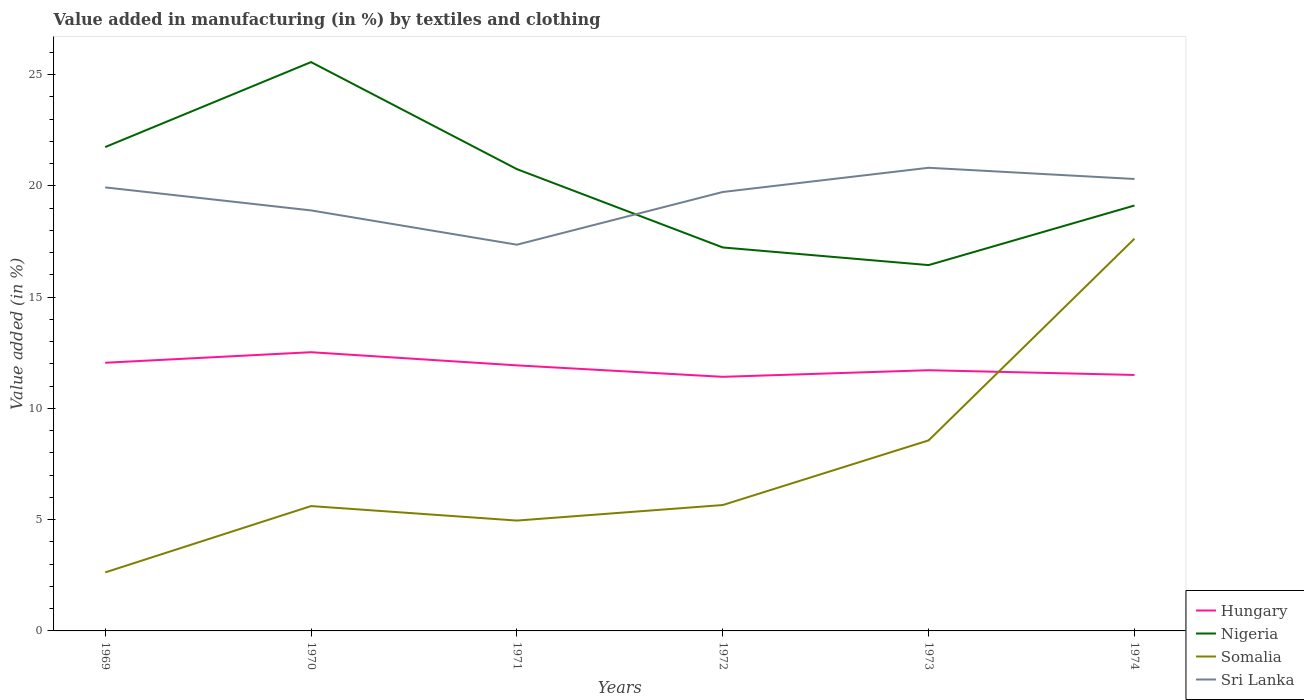How many different coloured lines are there?
Offer a very short reply. 4. Across all years, what is the maximum percentage of value added in manufacturing by textiles and clothing in Sri Lanka?
Ensure brevity in your answer.  17.36. What is the total percentage of value added in manufacturing by textiles and clothing in Somalia in the graph?
Offer a very short reply. -2.91. What is the difference between the highest and the second highest percentage of value added in manufacturing by textiles and clothing in Sri Lanka?
Provide a short and direct response. 3.46. How many lines are there?
Your answer should be compact. 4. How many years are there in the graph?
Keep it short and to the point. 6. Are the values on the major ticks of Y-axis written in scientific E-notation?
Your response must be concise. No. Where does the legend appear in the graph?
Provide a succinct answer. Bottom right. How many legend labels are there?
Give a very brief answer. 4. How are the legend labels stacked?
Your response must be concise. Vertical. What is the title of the graph?
Keep it short and to the point. Value added in manufacturing (in %) by textiles and clothing. Does "Marshall Islands" appear as one of the legend labels in the graph?
Give a very brief answer. No. What is the label or title of the X-axis?
Offer a very short reply. Years. What is the label or title of the Y-axis?
Your answer should be very brief. Value added (in %). What is the Value added (in %) in Hungary in 1969?
Your response must be concise. 12.05. What is the Value added (in %) of Nigeria in 1969?
Keep it short and to the point. 21.75. What is the Value added (in %) in Somalia in 1969?
Keep it short and to the point. 2.63. What is the Value added (in %) in Sri Lanka in 1969?
Offer a very short reply. 19.93. What is the Value added (in %) of Hungary in 1970?
Ensure brevity in your answer.  12.53. What is the Value added (in %) in Nigeria in 1970?
Offer a terse response. 25.57. What is the Value added (in %) in Somalia in 1970?
Your response must be concise. 5.61. What is the Value added (in %) of Sri Lanka in 1970?
Provide a succinct answer. 18.9. What is the Value added (in %) of Hungary in 1971?
Your answer should be compact. 11.94. What is the Value added (in %) in Nigeria in 1971?
Give a very brief answer. 20.75. What is the Value added (in %) of Somalia in 1971?
Make the answer very short. 4.96. What is the Value added (in %) of Sri Lanka in 1971?
Your response must be concise. 17.36. What is the Value added (in %) of Hungary in 1972?
Offer a very short reply. 11.42. What is the Value added (in %) of Nigeria in 1972?
Provide a short and direct response. 17.23. What is the Value added (in %) in Somalia in 1972?
Provide a short and direct response. 5.66. What is the Value added (in %) of Sri Lanka in 1972?
Your response must be concise. 19.73. What is the Value added (in %) in Hungary in 1973?
Your answer should be compact. 11.72. What is the Value added (in %) in Nigeria in 1973?
Your response must be concise. 16.44. What is the Value added (in %) of Somalia in 1973?
Ensure brevity in your answer.  8.56. What is the Value added (in %) in Sri Lanka in 1973?
Ensure brevity in your answer.  20.82. What is the Value added (in %) of Hungary in 1974?
Your answer should be compact. 11.5. What is the Value added (in %) in Nigeria in 1974?
Offer a terse response. 19.12. What is the Value added (in %) in Somalia in 1974?
Offer a terse response. 17.63. What is the Value added (in %) in Sri Lanka in 1974?
Provide a succinct answer. 20.31. Across all years, what is the maximum Value added (in %) of Hungary?
Offer a terse response. 12.53. Across all years, what is the maximum Value added (in %) in Nigeria?
Ensure brevity in your answer.  25.57. Across all years, what is the maximum Value added (in %) of Somalia?
Your answer should be compact. 17.63. Across all years, what is the maximum Value added (in %) of Sri Lanka?
Your answer should be compact. 20.82. Across all years, what is the minimum Value added (in %) of Hungary?
Make the answer very short. 11.42. Across all years, what is the minimum Value added (in %) of Nigeria?
Offer a very short reply. 16.44. Across all years, what is the minimum Value added (in %) in Somalia?
Your answer should be very brief. 2.63. Across all years, what is the minimum Value added (in %) of Sri Lanka?
Ensure brevity in your answer.  17.36. What is the total Value added (in %) in Hungary in the graph?
Your answer should be very brief. 71.15. What is the total Value added (in %) of Nigeria in the graph?
Make the answer very short. 120.86. What is the total Value added (in %) of Somalia in the graph?
Provide a short and direct response. 45.05. What is the total Value added (in %) of Sri Lanka in the graph?
Provide a succinct answer. 117.05. What is the difference between the Value added (in %) in Hungary in 1969 and that in 1970?
Your response must be concise. -0.47. What is the difference between the Value added (in %) in Nigeria in 1969 and that in 1970?
Give a very brief answer. -3.82. What is the difference between the Value added (in %) of Somalia in 1969 and that in 1970?
Provide a succinct answer. -2.98. What is the difference between the Value added (in %) of Sri Lanka in 1969 and that in 1970?
Your answer should be very brief. 1.03. What is the difference between the Value added (in %) in Hungary in 1969 and that in 1971?
Offer a very short reply. 0.12. What is the difference between the Value added (in %) in Nigeria in 1969 and that in 1971?
Provide a succinct answer. 0.99. What is the difference between the Value added (in %) of Somalia in 1969 and that in 1971?
Give a very brief answer. -2.33. What is the difference between the Value added (in %) of Sri Lanka in 1969 and that in 1971?
Offer a very short reply. 2.58. What is the difference between the Value added (in %) of Hungary in 1969 and that in 1972?
Offer a very short reply. 0.63. What is the difference between the Value added (in %) of Nigeria in 1969 and that in 1972?
Your response must be concise. 4.51. What is the difference between the Value added (in %) of Somalia in 1969 and that in 1972?
Your response must be concise. -3.03. What is the difference between the Value added (in %) of Sri Lanka in 1969 and that in 1972?
Ensure brevity in your answer.  0.21. What is the difference between the Value added (in %) of Hungary in 1969 and that in 1973?
Offer a terse response. 0.34. What is the difference between the Value added (in %) of Nigeria in 1969 and that in 1973?
Give a very brief answer. 5.31. What is the difference between the Value added (in %) in Somalia in 1969 and that in 1973?
Offer a terse response. -5.93. What is the difference between the Value added (in %) in Sri Lanka in 1969 and that in 1973?
Provide a succinct answer. -0.88. What is the difference between the Value added (in %) in Hungary in 1969 and that in 1974?
Provide a succinct answer. 0.55. What is the difference between the Value added (in %) in Nigeria in 1969 and that in 1974?
Provide a short and direct response. 2.63. What is the difference between the Value added (in %) in Somalia in 1969 and that in 1974?
Provide a short and direct response. -15. What is the difference between the Value added (in %) in Sri Lanka in 1969 and that in 1974?
Your response must be concise. -0.38. What is the difference between the Value added (in %) of Hungary in 1970 and that in 1971?
Ensure brevity in your answer.  0.59. What is the difference between the Value added (in %) in Nigeria in 1970 and that in 1971?
Offer a very short reply. 4.81. What is the difference between the Value added (in %) of Somalia in 1970 and that in 1971?
Keep it short and to the point. 0.65. What is the difference between the Value added (in %) in Sri Lanka in 1970 and that in 1971?
Your response must be concise. 1.54. What is the difference between the Value added (in %) in Hungary in 1970 and that in 1972?
Ensure brevity in your answer.  1.11. What is the difference between the Value added (in %) of Nigeria in 1970 and that in 1972?
Provide a short and direct response. 8.33. What is the difference between the Value added (in %) in Somalia in 1970 and that in 1972?
Your answer should be compact. -0.05. What is the difference between the Value added (in %) in Sri Lanka in 1970 and that in 1972?
Offer a very short reply. -0.83. What is the difference between the Value added (in %) in Hungary in 1970 and that in 1973?
Offer a very short reply. 0.81. What is the difference between the Value added (in %) in Nigeria in 1970 and that in 1973?
Your answer should be very brief. 9.12. What is the difference between the Value added (in %) in Somalia in 1970 and that in 1973?
Keep it short and to the point. -2.95. What is the difference between the Value added (in %) of Sri Lanka in 1970 and that in 1973?
Give a very brief answer. -1.92. What is the difference between the Value added (in %) of Hungary in 1970 and that in 1974?
Keep it short and to the point. 1.02. What is the difference between the Value added (in %) in Nigeria in 1970 and that in 1974?
Your answer should be compact. 6.45. What is the difference between the Value added (in %) in Somalia in 1970 and that in 1974?
Give a very brief answer. -12.02. What is the difference between the Value added (in %) in Sri Lanka in 1970 and that in 1974?
Your answer should be very brief. -1.41. What is the difference between the Value added (in %) of Hungary in 1971 and that in 1972?
Make the answer very short. 0.52. What is the difference between the Value added (in %) in Nigeria in 1971 and that in 1972?
Your answer should be compact. 3.52. What is the difference between the Value added (in %) of Somalia in 1971 and that in 1972?
Ensure brevity in your answer.  -0.7. What is the difference between the Value added (in %) of Sri Lanka in 1971 and that in 1972?
Your answer should be compact. -2.37. What is the difference between the Value added (in %) in Hungary in 1971 and that in 1973?
Offer a terse response. 0.22. What is the difference between the Value added (in %) of Nigeria in 1971 and that in 1973?
Offer a terse response. 4.31. What is the difference between the Value added (in %) in Somalia in 1971 and that in 1973?
Your response must be concise. -3.6. What is the difference between the Value added (in %) in Sri Lanka in 1971 and that in 1973?
Give a very brief answer. -3.46. What is the difference between the Value added (in %) of Hungary in 1971 and that in 1974?
Provide a short and direct response. 0.43. What is the difference between the Value added (in %) of Nigeria in 1971 and that in 1974?
Provide a succinct answer. 1.64. What is the difference between the Value added (in %) in Somalia in 1971 and that in 1974?
Provide a succinct answer. -12.67. What is the difference between the Value added (in %) in Sri Lanka in 1971 and that in 1974?
Give a very brief answer. -2.95. What is the difference between the Value added (in %) of Hungary in 1972 and that in 1973?
Offer a very short reply. -0.3. What is the difference between the Value added (in %) in Nigeria in 1972 and that in 1973?
Give a very brief answer. 0.79. What is the difference between the Value added (in %) in Somalia in 1972 and that in 1973?
Your answer should be very brief. -2.91. What is the difference between the Value added (in %) in Sri Lanka in 1972 and that in 1973?
Keep it short and to the point. -1.09. What is the difference between the Value added (in %) in Hungary in 1972 and that in 1974?
Keep it short and to the point. -0.08. What is the difference between the Value added (in %) of Nigeria in 1972 and that in 1974?
Provide a succinct answer. -1.88. What is the difference between the Value added (in %) in Somalia in 1972 and that in 1974?
Make the answer very short. -11.97. What is the difference between the Value added (in %) in Sri Lanka in 1972 and that in 1974?
Your answer should be compact. -0.58. What is the difference between the Value added (in %) of Hungary in 1973 and that in 1974?
Provide a succinct answer. 0.21. What is the difference between the Value added (in %) of Nigeria in 1973 and that in 1974?
Provide a succinct answer. -2.68. What is the difference between the Value added (in %) of Somalia in 1973 and that in 1974?
Give a very brief answer. -9.07. What is the difference between the Value added (in %) in Sri Lanka in 1973 and that in 1974?
Offer a terse response. 0.5. What is the difference between the Value added (in %) of Hungary in 1969 and the Value added (in %) of Nigeria in 1970?
Provide a short and direct response. -13.51. What is the difference between the Value added (in %) in Hungary in 1969 and the Value added (in %) in Somalia in 1970?
Offer a very short reply. 6.44. What is the difference between the Value added (in %) in Hungary in 1969 and the Value added (in %) in Sri Lanka in 1970?
Provide a short and direct response. -6.85. What is the difference between the Value added (in %) of Nigeria in 1969 and the Value added (in %) of Somalia in 1970?
Keep it short and to the point. 16.14. What is the difference between the Value added (in %) of Nigeria in 1969 and the Value added (in %) of Sri Lanka in 1970?
Make the answer very short. 2.85. What is the difference between the Value added (in %) in Somalia in 1969 and the Value added (in %) in Sri Lanka in 1970?
Your answer should be compact. -16.27. What is the difference between the Value added (in %) in Hungary in 1969 and the Value added (in %) in Nigeria in 1971?
Your answer should be compact. -8.7. What is the difference between the Value added (in %) in Hungary in 1969 and the Value added (in %) in Somalia in 1971?
Keep it short and to the point. 7.09. What is the difference between the Value added (in %) of Hungary in 1969 and the Value added (in %) of Sri Lanka in 1971?
Your answer should be very brief. -5.31. What is the difference between the Value added (in %) of Nigeria in 1969 and the Value added (in %) of Somalia in 1971?
Make the answer very short. 16.79. What is the difference between the Value added (in %) in Nigeria in 1969 and the Value added (in %) in Sri Lanka in 1971?
Give a very brief answer. 4.39. What is the difference between the Value added (in %) in Somalia in 1969 and the Value added (in %) in Sri Lanka in 1971?
Your response must be concise. -14.73. What is the difference between the Value added (in %) of Hungary in 1969 and the Value added (in %) of Nigeria in 1972?
Keep it short and to the point. -5.18. What is the difference between the Value added (in %) in Hungary in 1969 and the Value added (in %) in Somalia in 1972?
Offer a terse response. 6.39. What is the difference between the Value added (in %) of Hungary in 1969 and the Value added (in %) of Sri Lanka in 1972?
Provide a short and direct response. -7.68. What is the difference between the Value added (in %) of Nigeria in 1969 and the Value added (in %) of Somalia in 1972?
Keep it short and to the point. 16.09. What is the difference between the Value added (in %) of Nigeria in 1969 and the Value added (in %) of Sri Lanka in 1972?
Keep it short and to the point. 2.02. What is the difference between the Value added (in %) in Somalia in 1969 and the Value added (in %) in Sri Lanka in 1972?
Your answer should be compact. -17.1. What is the difference between the Value added (in %) in Hungary in 1969 and the Value added (in %) in Nigeria in 1973?
Your answer should be very brief. -4.39. What is the difference between the Value added (in %) of Hungary in 1969 and the Value added (in %) of Somalia in 1973?
Your answer should be compact. 3.49. What is the difference between the Value added (in %) in Hungary in 1969 and the Value added (in %) in Sri Lanka in 1973?
Your answer should be compact. -8.76. What is the difference between the Value added (in %) of Nigeria in 1969 and the Value added (in %) of Somalia in 1973?
Give a very brief answer. 13.18. What is the difference between the Value added (in %) of Nigeria in 1969 and the Value added (in %) of Sri Lanka in 1973?
Offer a terse response. 0.93. What is the difference between the Value added (in %) of Somalia in 1969 and the Value added (in %) of Sri Lanka in 1973?
Your response must be concise. -18.19. What is the difference between the Value added (in %) in Hungary in 1969 and the Value added (in %) in Nigeria in 1974?
Give a very brief answer. -7.07. What is the difference between the Value added (in %) in Hungary in 1969 and the Value added (in %) in Somalia in 1974?
Give a very brief answer. -5.58. What is the difference between the Value added (in %) of Hungary in 1969 and the Value added (in %) of Sri Lanka in 1974?
Keep it short and to the point. -8.26. What is the difference between the Value added (in %) of Nigeria in 1969 and the Value added (in %) of Somalia in 1974?
Offer a very short reply. 4.12. What is the difference between the Value added (in %) of Nigeria in 1969 and the Value added (in %) of Sri Lanka in 1974?
Your response must be concise. 1.43. What is the difference between the Value added (in %) in Somalia in 1969 and the Value added (in %) in Sri Lanka in 1974?
Your answer should be very brief. -17.68. What is the difference between the Value added (in %) of Hungary in 1970 and the Value added (in %) of Nigeria in 1971?
Keep it short and to the point. -8.23. What is the difference between the Value added (in %) of Hungary in 1970 and the Value added (in %) of Somalia in 1971?
Keep it short and to the point. 7.57. What is the difference between the Value added (in %) in Hungary in 1970 and the Value added (in %) in Sri Lanka in 1971?
Provide a succinct answer. -4.83. What is the difference between the Value added (in %) of Nigeria in 1970 and the Value added (in %) of Somalia in 1971?
Your answer should be compact. 20.61. What is the difference between the Value added (in %) of Nigeria in 1970 and the Value added (in %) of Sri Lanka in 1971?
Keep it short and to the point. 8.21. What is the difference between the Value added (in %) of Somalia in 1970 and the Value added (in %) of Sri Lanka in 1971?
Give a very brief answer. -11.75. What is the difference between the Value added (in %) in Hungary in 1970 and the Value added (in %) in Nigeria in 1972?
Provide a short and direct response. -4.71. What is the difference between the Value added (in %) in Hungary in 1970 and the Value added (in %) in Somalia in 1972?
Offer a terse response. 6.87. What is the difference between the Value added (in %) of Hungary in 1970 and the Value added (in %) of Sri Lanka in 1972?
Provide a short and direct response. -7.2. What is the difference between the Value added (in %) of Nigeria in 1970 and the Value added (in %) of Somalia in 1972?
Your answer should be compact. 19.91. What is the difference between the Value added (in %) in Nigeria in 1970 and the Value added (in %) in Sri Lanka in 1972?
Your response must be concise. 5.84. What is the difference between the Value added (in %) of Somalia in 1970 and the Value added (in %) of Sri Lanka in 1972?
Offer a very short reply. -14.12. What is the difference between the Value added (in %) of Hungary in 1970 and the Value added (in %) of Nigeria in 1973?
Give a very brief answer. -3.92. What is the difference between the Value added (in %) of Hungary in 1970 and the Value added (in %) of Somalia in 1973?
Your answer should be compact. 3.96. What is the difference between the Value added (in %) of Hungary in 1970 and the Value added (in %) of Sri Lanka in 1973?
Offer a terse response. -8.29. What is the difference between the Value added (in %) in Nigeria in 1970 and the Value added (in %) in Somalia in 1973?
Offer a very short reply. 17. What is the difference between the Value added (in %) of Nigeria in 1970 and the Value added (in %) of Sri Lanka in 1973?
Your answer should be very brief. 4.75. What is the difference between the Value added (in %) in Somalia in 1970 and the Value added (in %) in Sri Lanka in 1973?
Your response must be concise. -15.2. What is the difference between the Value added (in %) of Hungary in 1970 and the Value added (in %) of Nigeria in 1974?
Provide a succinct answer. -6.59. What is the difference between the Value added (in %) of Hungary in 1970 and the Value added (in %) of Somalia in 1974?
Make the answer very short. -5.1. What is the difference between the Value added (in %) of Hungary in 1970 and the Value added (in %) of Sri Lanka in 1974?
Your response must be concise. -7.79. What is the difference between the Value added (in %) of Nigeria in 1970 and the Value added (in %) of Somalia in 1974?
Your answer should be very brief. 7.94. What is the difference between the Value added (in %) of Nigeria in 1970 and the Value added (in %) of Sri Lanka in 1974?
Offer a terse response. 5.25. What is the difference between the Value added (in %) of Somalia in 1970 and the Value added (in %) of Sri Lanka in 1974?
Provide a succinct answer. -14.7. What is the difference between the Value added (in %) in Hungary in 1971 and the Value added (in %) in Nigeria in 1972?
Your answer should be very brief. -5.3. What is the difference between the Value added (in %) of Hungary in 1971 and the Value added (in %) of Somalia in 1972?
Offer a terse response. 6.28. What is the difference between the Value added (in %) in Hungary in 1971 and the Value added (in %) in Sri Lanka in 1972?
Your response must be concise. -7.79. What is the difference between the Value added (in %) of Nigeria in 1971 and the Value added (in %) of Somalia in 1972?
Provide a succinct answer. 15.1. What is the difference between the Value added (in %) in Nigeria in 1971 and the Value added (in %) in Sri Lanka in 1972?
Keep it short and to the point. 1.03. What is the difference between the Value added (in %) of Somalia in 1971 and the Value added (in %) of Sri Lanka in 1972?
Keep it short and to the point. -14.77. What is the difference between the Value added (in %) of Hungary in 1971 and the Value added (in %) of Nigeria in 1973?
Offer a terse response. -4.51. What is the difference between the Value added (in %) in Hungary in 1971 and the Value added (in %) in Somalia in 1973?
Ensure brevity in your answer.  3.37. What is the difference between the Value added (in %) of Hungary in 1971 and the Value added (in %) of Sri Lanka in 1973?
Your answer should be very brief. -8.88. What is the difference between the Value added (in %) in Nigeria in 1971 and the Value added (in %) in Somalia in 1973?
Give a very brief answer. 12.19. What is the difference between the Value added (in %) in Nigeria in 1971 and the Value added (in %) in Sri Lanka in 1973?
Provide a short and direct response. -0.06. What is the difference between the Value added (in %) in Somalia in 1971 and the Value added (in %) in Sri Lanka in 1973?
Keep it short and to the point. -15.86. What is the difference between the Value added (in %) in Hungary in 1971 and the Value added (in %) in Nigeria in 1974?
Make the answer very short. -7.18. What is the difference between the Value added (in %) of Hungary in 1971 and the Value added (in %) of Somalia in 1974?
Offer a terse response. -5.69. What is the difference between the Value added (in %) in Hungary in 1971 and the Value added (in %) in Sri Lanka in 1974?
Offer a terse response. -8.38. What is the difference between the Value added (in %) in Nigeria in 1971 and the Value added (in %) in Somalia in 1974?
Keep it short and to the point. 3.13. What is the difference between the Value added (in %) of Nigeria in 1971 and the Value added (in %) of Sri Lanka in 1974?
Your answer should be very brief. 0.44. What is the difference between the Value added (in %) in Somalia in 1971 and the Value added (in %) in Sri Lanka in 1974?
Provide a succinct answer. -15.35. What is the difference between the Value added (in %) in Hungary in 1972 and the Value added (in %) in Nigeria in 1973?
Give a very brief answer. -5.02. What is the difference between the Value added (in %) of Hungary in 1972 and the Value added (in %) of Somalia in 1973?
Provide a short and direct response. 2.86. What is the difference between the Value added (in %) in Hungary in 1972 and the Value added (in %) in Sri Lanka in 1973?
Ensure brevity in your answer.  -9.4. What is the difference between the Value added (in %) of Nigeria in 1972 and the Value added (in %) of Somalia in 1973?
Keep it short and to the point. 8.67. What is the difference between the Value added (in %) of Nigeria in 1972 and the Value added (in %) of Sri Lanka in 1973?
Provide a succinct answer. -3.58. What is the difference between the Value added (in %) in Somalia in 1972 and the Value added (in %) in Sri Lanka in 1973?
Provide a short and direct response. -15.16. What is the difference between the Value added (in %) in Hungary in 1972 and the Value added (in %) in Nigeria in 1974?
Offer a very short reply. -7.7. What is the difference between the Value added (in %) of Hungary in 1972 and the Value added (in %) of Somalia in 1974?
Offer a terse response. -6.21. What is the difference between the Value added (in %) in Hungary in 1972 and the Value added (in %) in Sri Lanka in 1974?
Keep it short and to the point. -8.89. What is the difference between the Value added (in %) of Nigeria in 1972 and the Value added (in %) of Somalia in 1974?
Offer a very short reply. -0.39. What is the difference between the Value added (in %) in Nigeria in 1972 and the Value added (in %) in Sri Lanka in 1974?
Provide a short and direct response. -3.08. What is the difference between the Value added (in %) of Somalia in 1972 and the Value added (in %) of Sri Lanka in 1974?
Your response must be concise. -14.65. What is the difference between the Value added (in %) in Hungary in 1973 and the Value added (in %) in Nigeria in 1974?
Offer a very short reply. -7.4. What is the difference between the Value added (in %) of Hungary in 1973 and the Value added (in %) of Somalia in 1974?
Provide a succinct answer. -5.91. What is the difference between the Value added (in %) of Hungary in 1973 and the Value added (in %) of Sri Lanka in 1974?
Your answer should be compact. -8.59. What is the difference between the Value added (in %) in Nigeria in 1973 and the Value added (in %) in Somalia in 1974?
Offer a very short reply. -1.19. What is the difference between the Value added (in %) of Nigeria in 1973 and the Value added (in %) of Sri Lanka in 1974?
Give a very brief answer. -3.87. What is the difference between the Value added (in %) of Somalia in 1973 and the Value added (in %) of Sri Lanka in 1974?
Offer a very short reply. -11.75. What is the average Value added (in %) of Hungary per year?
Keep it short and to the point. 11.86. What is the average Value added (in %) in Nigeria per year?
Make the answer very short. 20.14. What is the average Value added (in %) in Somalia per year?
Your answer should be compact. 7.51. What is the average Value added (in %) in Sri Lanka per year?
Provide a short and direct response. 19.51. In the year 1969, what is the difference between the Value added (in %) in Hungary and Value added (in %) in Nigeria?
Offer a very short reply. -9.69. In the year 1969, what is the difference between the Value added (in %) of Hungary and Value added (in %) of Somalia?
Offer a very short reply. 9.42. In the year 1969, what is the difference between the Value added (in %) in Hungary and Value added (in %) in Sri Lanka?
Keep it short and to the point. -7.88. In the year 1969, what is the difference between the Value added (in %) of Nigeria and Value added (in %) of Somalia?
Offer a very short reply. 19.12. In the year 1969, what is the difference between the Value added (in %) in Nigeria and Value added (in %) in Sri Lanka?
Offer a terse response. 1.81. In the year 1969, what is the difference between the Value added (in %) of Somalia and Value added (in %) of Sri Lanka?
Ensure brevity in your answer.  -17.3. In the year 1970, what is the difference between the Value added (in %) of Hungary and Value added (in %) of Nigeria?
Your answer should be compact. -13.04. In the year 1970, what is the difference between the Value added (in %) in Hungary and Value added (in %) in Somalia?
Keep it short and to the point. 6.91. In the year 1970, what is the difference between the Value added (in %) in Hungary and Value added (in %) in Sri Lanka?
Your answer should be compact. -6.37. In the year 1970, what is the difference between the Value added (in %) of Nigeria and Value added (in %) of Somalia?
Provide a short and direct response. 19.95. In the year 1970, what is the difference between the Value added (in %) of Nigeria and Value added (in %) of Sri Lanka?
Provide a short and direct response. 6.67. In the year 1970, what is the difference between the Value added (in %) of Somalia and Value added (in %) of Sri Lanka?
Your response must be concise. -13.29. In the year 1971, what is the difference between the Value added (in %) of Hungary and Value added (in %) of Nigeria?
Provide a succinct answer. -8.82. In the year 1971, what is the difference between the Value added (in %) of Hungary and Value added (in %) of Somalia?
Offer a terse response. 6.97. In the year 1971, what is the difference between the Value added (in %) in Hungary and Value added (in %) in Sri Lanka?
Keep it short and to the point. -5.42. In the year 1971, what is the difference between the Value added (in %) of Nigeria and Value added (in %) of Somalia?
Provide a succinct answer. 15.79. In the year 1971, what is the difference between the Value added (in %) of Nigeria and Value added (in %) of Sri Lanka?
Ensure brevity in your answer.  3.4. In the year 1971, what is the difference between the Value added (in %) of Somalia and Value added (in %) of Sri Lanka?
Ensure brevity in your answer.  -12.4. In the year 1972, what is the difference between the Value added (in %) in Hungary and Value added (in %) in Nigeria?
Make the answer very short. -5.81. In the year 1972, what is the difference between the Value added (in %) in Hungary and Value added (in %) in Somalia?
Provide a short and direct response. 5.76. In the year 1972, what is the difference between the Value added (in %) in Hungary and Value added (in %) in Sri Lanka?
Offer a very short reply. -8.31. In the year 1972, what is the difference between the Value added (in %) of Nigeria and Value added (in %) of Somalia?
Your answer should be very brief. 11.58. In the year 1972, what is the difference between the Value added (in %) of Nigeria and Value added (in %) of Sri Lanka?
Ensure brevity in your answer.  -2.49. In the year 1972, what is the difference between the Value added (in %) in Somalia and Value added (in %) in Sri Lanka?
Offer a very short reply. -14.07. In the year 1973, what is the difference between the Value added (in %) in Hungary and Value added (in %) in Nigeria?
Offer a very short reply. -4.72. In the year 1973, what is the difference between the Value added (in %) in Hungary and Value added (in %) in Somalia?
Keep it short and to the point. 3.15. In the year 1973, what is the difference between the Value added (in %) of Hungary and Value added (in %) of Sri Lanka?
Ensure brevity in your answer.  -9.1. In the year 1973, what is the difference between the Value added (in %) of Nigeria and Value added (in %) of Somalia?
Make the answer very short. 7.88. In the year 1973, what is the difference between the Value added (in %) of Nigeria and Value added (in %) of Sri Lanka?
Offer a very short reply. -4.37. In the year 1973, what is the difference between the Value added (in %) of Somalia and Value added (in %) of Sri Lanka?
Offer a terse response. -12.25. In the year 1974, what is the difference between the Value added (in %) in Hungary and Value added (in %) in Nigeria?
Offer a terse response. -7.62. In the year 1974, what is the difference between the Value added (in %) in Hungary and Value added (in %) in Somalia?
Give a very brief answer. -6.12. In the year 1974, what is the difference between the Value added (in %) of Hungary and Value added (in %) of Sri Lanka?
Your answer should be very brief. -8.81. In the year 1974, what is the difference between the Value added (in %) in Nigeria and Value added (in %) in Somalia?
Give a very brief answer. 1.49. In the year 1974, what is the difference between the Value added (in %) of Nigeria and Value added (in %) of Sri Lanka?
Your answer should be compact. -1.19. In the year 1974, what is the difference between the Value added (in %) of Somalia and Value added (in %) of Sri Lanka?
Give a very brief answer. -2.68. What is the ratio of the Value added (in %) of Hungary in 1969 to that in 1970?
Provide a succinct answer. 0.96. What is the ratio of the Value added (in %) in Nigeria in 1969 to that in 1970?
Keep it short and to the point. 0.85. What is the ratio of the Value added (in %) in Somalia in 1969 to that in 1970?
Your answer should be very brief. 0.47. What is the ratio of the Value added (in %) of Sri Lanka in 1969 to that in 1970?
Provide a succinct answer. 1.05. What is the ratio of the Value added (in %) of Hungary in 1969 to that in 1971?
Your answer should be compact. 1.01. What is the ratio of the Value added (in %) of Nigeria in 1969 to that in 1971?
Your answer should be very brief. 1.05. What is the ratio of the Value added (in %) of Somalia in 1969 to that in 1971?
Give a very brief answer. 0.53. What is the ratio of the Value added (in %) of Sri Lanka in 1969 to that in 1971?
Keep it short and to the point. 1.15. What is the ratio of the Value added (in %) in Hungary in 1969 to that in 1972?
Keep it short and to the point. 1.06. What is the ratio of the Value added (in %) of Nigeria in 1969 to that in 1972?
Keep it short and to the point. 1.26. What is the ratio of the Value added (in %) of Somalia in 1969 to that in 1972?
Offer a very short reply. 0.46. What is the ratio of the Value added (in %) of Sri Lanka in 1969 to that in 1972?
Provide a short and direct response. 1.01. What is the ratio of the Value added (in %) of Hungary in 1969 to that in 1973?
Ensure brevity in your answer.  1.03. What is the ratio of the Value added (in %) in Nigeria in 1969 to that in 1973?
Your response must be concise. 1.32. What is the ratio of the Value added (in %) in Somalia in 1969 to that in 1973?
Offer a very short reply. 0.31. What is the ratio of the Value added (in %) of Sri Lanka in 1969 to that in 1973?
Give a very brief answer. 0.96. What is the ratio of the Value added (in %) in Hungary in 1969 to that in 1974?
Offer a very short reply. 1.05. What is the ratio of the Value added (in %) of Nigeria in 1969 to that in 1974?
Provide a short and direct response. 1.14. What is the ratio of the Value added (in %) of Somalia in 1969 to that in 1974?
Keep it short and to the point. 0.15. What is the ratio of the Value added (in %) of Sri Lanka in 1969 to that in 1974?
Your answer should be compact. 0.98. What is the ratio of the Value added (in %) in Hungary in 1970 to that in 1971?
Your answer should be compact. 1.05. What is the ratio of the Value added (in %) in Nigeria in 1970 to that in 1971?
Give a very brief answer. 1.23. What is the ratio of the Value added (in %) of Somalia in 1970 to that in 1971?
Keep it short and to the point. 1.13. What is the ratio of the Value added (in %) in Sri Lanka in 1970 to that in 1971?
Give a very brief answer. 1.09. What is the ratio of the Value added (in %) in Hungary in 1970 to that in 1972?
Provide a short and direct response. 1.1. What is the ratio of the Value added (in %) of Nigeria in 1970 to that in 1972?
Offer a very short reply. 1.48. What is the ratio of the Value added (in %) of Somalia in 1970 to that in 1972?
Offer a very short reply. 0.99. What is the ratio of the Value added (in %) in Sri Lanka in 1970 to that in 1972?
Ensure brevity in your answer.  0.96. What is the ratio of the Value added (in %) of Hungary in 1970 to that in 1973?
Make the answer very short. 1.07. What is the ratio of the Value added (in %) of Nigeria in 1970 to that in 1973?
Offer a very short reply. 1.55. What is the ratio of the Value added (in %) in Somalia in 1970 to that in 1973?
Provide a succinct answer. 0.66. What is the ratio of the Value added (in %) of Sri Lanka in 1970 to that in 1973?
Make the answer very short. 0.91. What is the ratio of the Value added (in %) of Hungary in 1970 to that in 1974?
Provide a succinct answer. 1.09. What is the ratio of the Value added (in %) of Nigeria in 1970 to that in 1974?
Make the answer very short. 1.34. What is the ratio of the Value added (in %) in Somalia in 1970 to that in 1974?
Your answer should be compact. 0.32. What is the ratio of the Value added (in %) of Sri Lanka in 1970 to that in 1974?
Give a very brief answer. 0.93. What is the ratio of the Value added (in %) of Hungary in 1971 to that in 1972?
Your answer should be compact. 1.05. What is the ratio of the Value added (in %) of Nigeria in 1971 to that in 1972?
Offer a terse response. 1.2. What is the ratio of the Value added (in %) in Somalia in 1971 to that in 1972?
Provide a short and direct response. 0.88. What is the ratio of the Value added (in %) of Sri Lanka in 1971 to that in 1972?
Ensure brevity in your answer.  0.88. What is the ratio of the Value added (in %) in Hungary in 1971 to that in 1973?
Offer a terse response. 1.02. What is the ratio of the Value added (in %) of Nigeria in 1971 to that in 1973?
Your answer should be compact. 1.26. What is the ratio of the Value added (in %) of Somalia in 1971 to that in 1973?
Your answer should be compact. 0.58. What is the ratio of the Value added (in %) of Sri Lanka in 1971 to that in 1973?
Provide a short and direct response. 0.83. What is the ratio of the Value added (in %) of Hungary in 1971 to that in 1974?
Provide a short and direct response. 1.04. What is the ratio of the Value added (in %) of Nigeria in 1971 to that in 1974?
Give a very brief answer. 1.09. What is the ratio of the Value added (in %) in Somalia in 1971 to that in 1974?
Your response must be concise. 0.28. What is the ratio of the Value added (in %) in Sri Lanka in 1971 to that in 1974?
Ensure brevity in your answer.  0.85. What is the ratio of the Value added (in %) in Hungary in 1972 to that in 1973?
Offer a very short reply. 0.97. What is the ratio of the Value added (in %) in Nigeria in 1972 to that in 1973?
Ensure brevity in your answer.  1.05. What is the ratio of the Value added (in %) of Somalia in 1972 to that in 1973?
Your response must be concise. 0.66. What is the ratio of the Value added (in %) in Sri Lanka in 1972 to that in 1973?
Provide a succinct answer. 0.95. What is the ratio of the Value added (in %) of Hungary in 1972 to that in 1974?
Provide a succinct answer. 0.99. What is the ratio of the Value added (in %) of Nigeria in 1972 to that in 1974?
Keep it short and to the point. 0.9. What is the ratio of the Value added (in %) in Somalia in 1972 to that in 1974?
Ensure brevity in your answer.  0.32. What is the ratio of the Value added (in %) in Sri Lanka in 1972 to that in 1974?
Your response must be concise. 0.97. What is the ratio of the Value added (in %) in Hungary in 1973 to that in 1974?
Your response must be concise. 1.02. What is the ratio of the Value added (in %) of Nigeria in 1973 to that in 1974?
Your answer should be very brief. 0.86. What is the ratio of the Value added (in %) of Somalia in 1973 to that in 1974?
Offer a very short reply. 0.49. What is the ratio of the Value added (in %) of Sri Lanka in 1973 to that in 1974?
Make the answer very short. 1.02. What is the difference between the highest and the second highest Value added (in %) in Hungary?
Keep it short and to the point. 0.47. What is the difference between the highest and the second highest Value added (in %) in Nigeria?
Make the answer very short. 3.82. What is the difference between the highest and the second highest Value added (in %) in Somalia?
Provide a short and direct response. 9.07. What is the difference between the highest and the second highest Value added (in %) of Sri Lanka?
Offer a terse response. 0.5. What is the difference between the highest and the lowest Value added (in %) in Hungary?
Your response must be concise. 1.11. What is the difference between the highest and the lowest Value added (in %) of Nigeria?
Your answer should be very brief. 9.12. What is the difference between the highest and the lowest Value added (in %) in Somalia?
Give a very brief answer. 15. What is the difference between the highest and the lowest Value added (in %) of Sri Lanka?
Offer a very short reply. 3.46. 